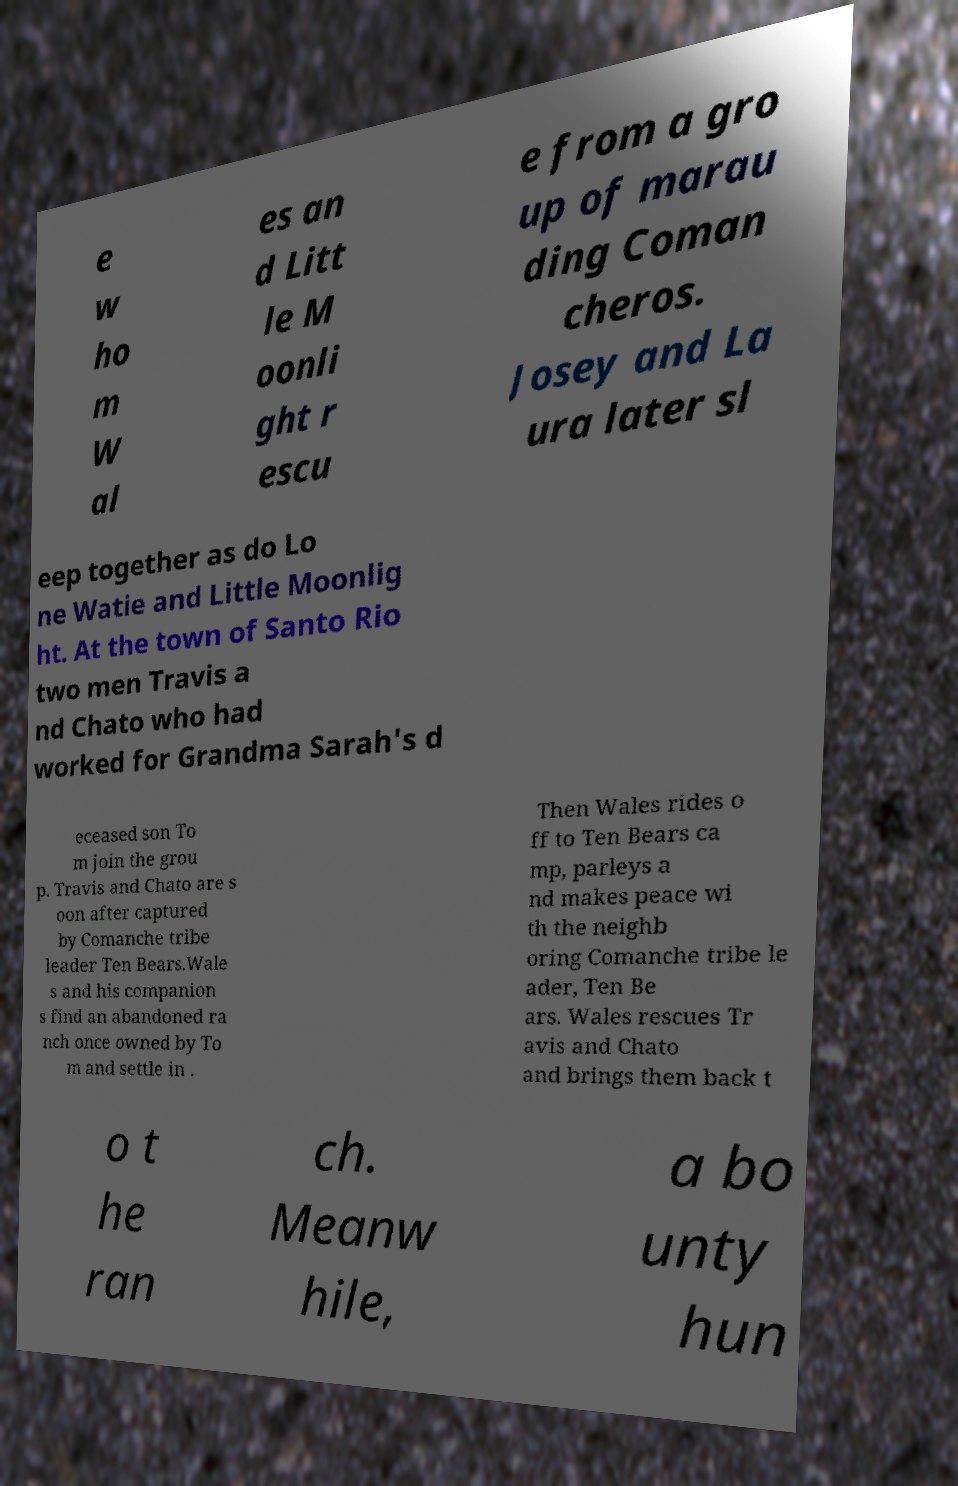For documentation purposes, I need the text within this image transcribed. Could you provide that? e w ho m W al es an d Litt le M oonli ght r escu e from a gro up of marau ding Coman cheros. Josey and La ura later sl eep together as do Lo ne Watie and Little Moonlig ht. At the town of Santo Rio two men Travis a nd Chato who had worked for Grandma Sarah's d eceased son To m join the grou p. Travis and Chato are s oon after captured by Comanche tribe leader Ten Bears.Wale s and his companion s find an abandoned ra nch once owned by To m and settle in . Then Wales rides o ff to Ten Bears ca mp, parleys a nd makes peace wi th the neighb oring Comanche tribe le ader, Ten Be ars. Wales rescues Tr avis and Chato and brings them back t o t he ran ch. Meanw hile, a bo unty hun 